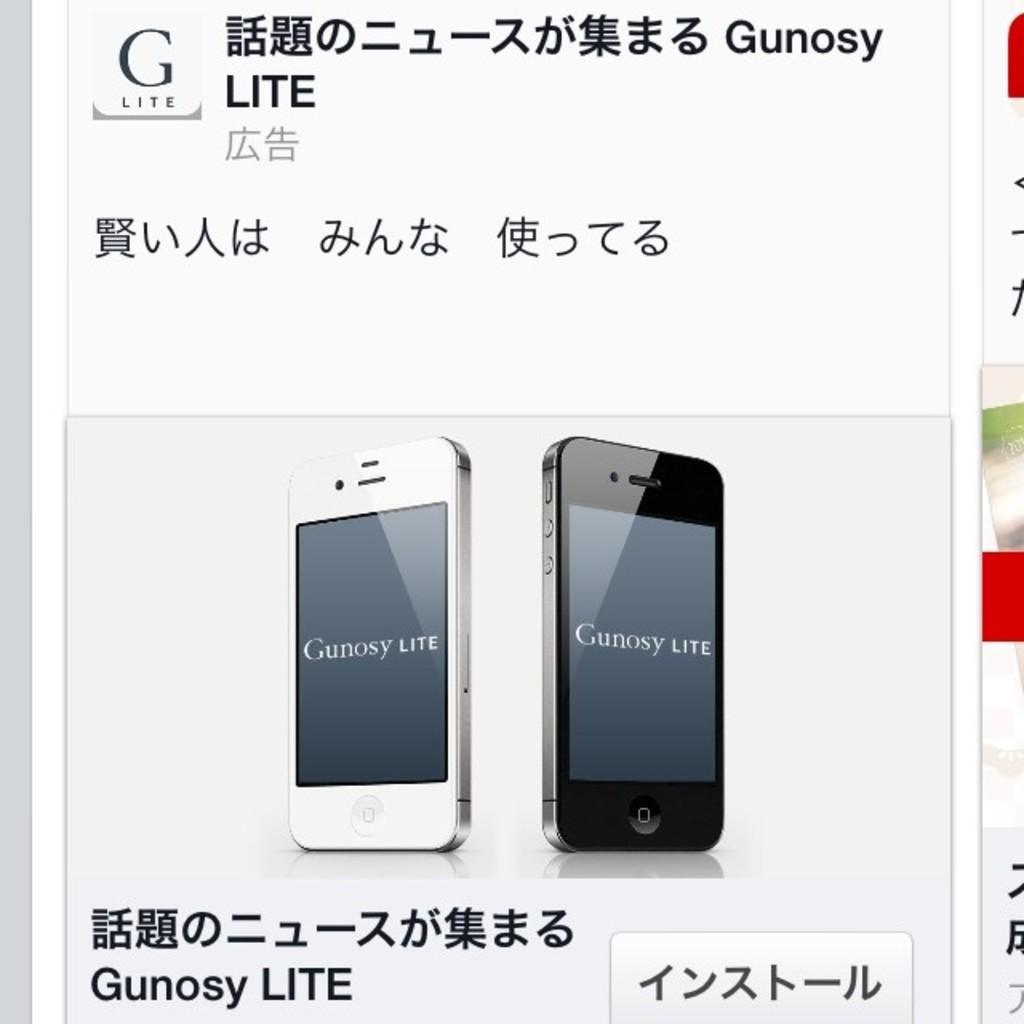<image>
Present a compact description of the photo's key features. display showing two gunosy lite phones, one black and the other white 